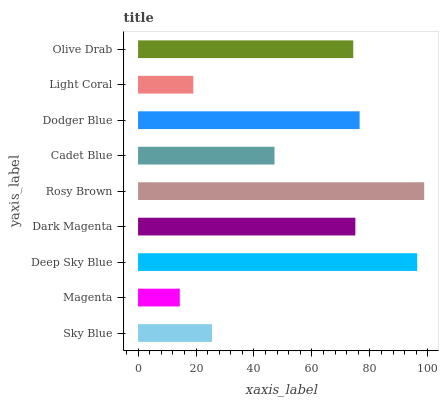Is Magenta the minimum?
Answer yes or no. Yes. Is Rosy Brown the maximum?
Answer yes or no. Yes. Is Deep Sky Blue the minimum?
Answer yes or no. No. Is Deep Sky Blue the maximum?
Answer yes or no. No. Is Deep Sky Blue greater than Magenta?
Answer yes or no. Yes. Is Magenta less than Deep Sky Blue?
Answer yes or no. Yes. Is Magenta greater than Deep Sky Blue?
Answer yes or no. No. Is Deep Sky Blue less than Magenta?
Answer yes or no. No. Is Olive Drab the high median?
Answer yes or no. Yes. Is Olive Drab the low median?
Answer yes or no. Yes. Is Deep Sky Blue the high median?
Answer yes or no. No. Is Deep Sky Blue the low median?
Answer yes or no. No. 